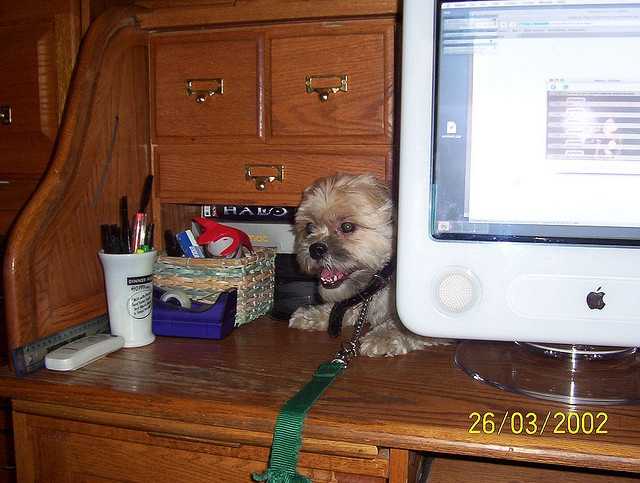Describe the objects in this image and their specific colors. I can see tv in maroon, white, darkgray, and lightblue tones, dog in maroon, gray, darkgray, and black tones, cup in maroon, darkgray, lightgray, and gray tones, book in maroon, darkgray, gray, and black tones, and remote in maroon, darkgray, gray, and black tones in this image. 